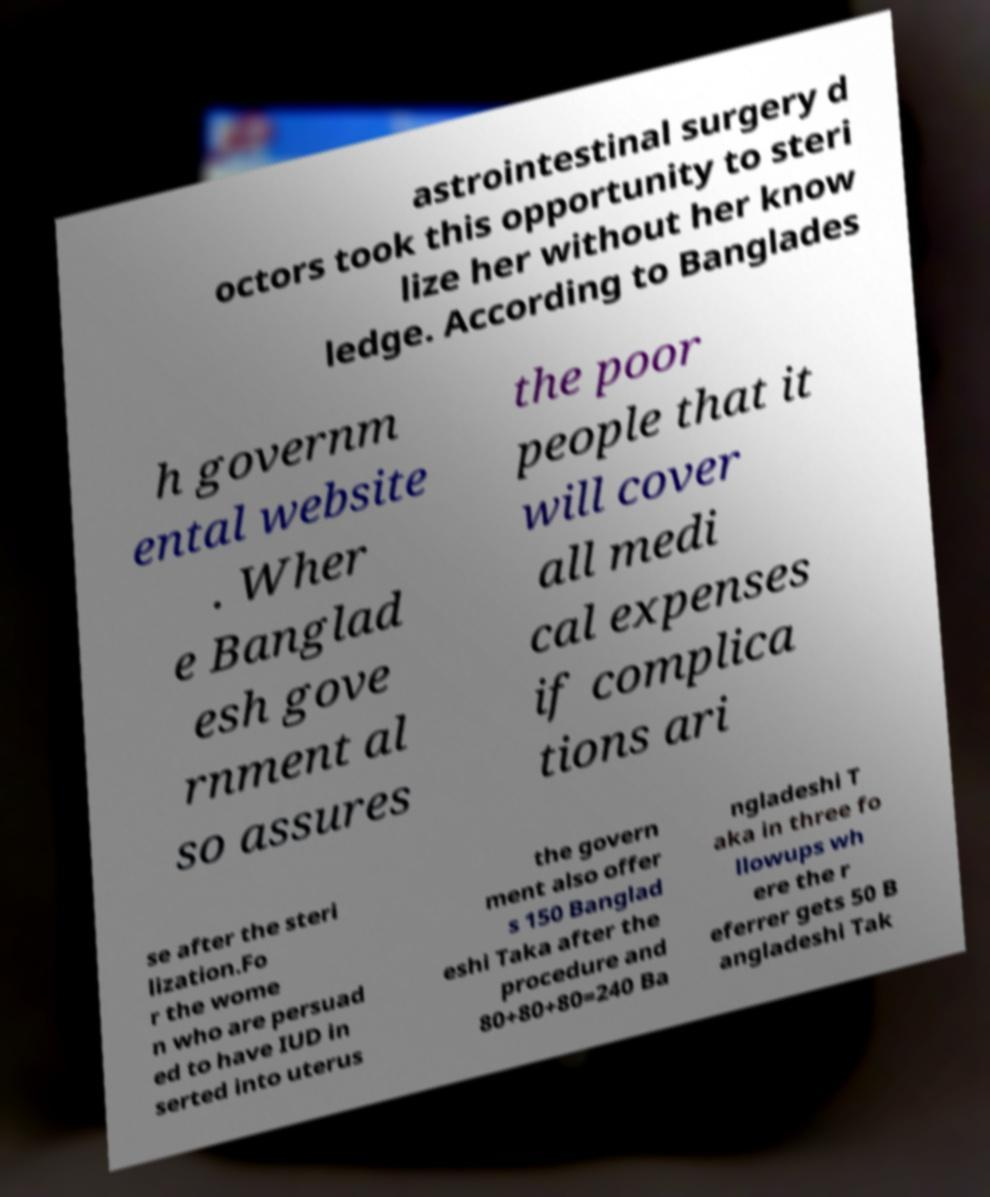Please identify and transcribe the text found in this image. astrointestinal surgery d octors took this opportunity to steri lize her without her know ledge. According to Banglades h governm ental website . Wher e Banglad esh gove rnment al so assures the poor people that it will cover all medi cal expenses if complica tions ari se after the steri lization.Fo r the wome n who are persuad ed to have IUD in serted into uterus the govern ment also offer s 150 Banglad eshi Taka after the procedure and 80+80+80=240 Ba ngladeshi T aka in three fo llowups wh ere the r eferrer gets 50 B angladeshi Tak 